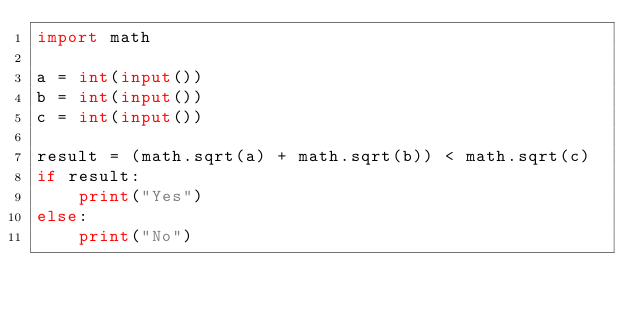<code> <loc_0><loc_0><loc_500><loc_500><_Python_>import math

a = int(input())
b = int(input())
c = int(input())

result = (math.sqrt(a) + math.sqrt(b)) < math.sqrt(c)
if result:
    print("Yes")
else:
    print("No")</code> 